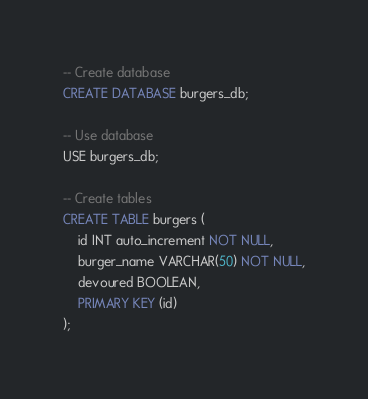Convert code to text. <code><loc_0><loc_0><loc_500><loc_500><_SQL_>
-- Create database
CREATE DATABASE burgers_db;

-- Use database
USE burgers_db;

-- Create tables
CREATE TABLE burgers (
    id INT auto_increment NOT NULL,
    burger_name VARCHAR(50) NOT NULL,
    devoured BOOLEAN,
    PRIMARY KEY (id)
);</code> 